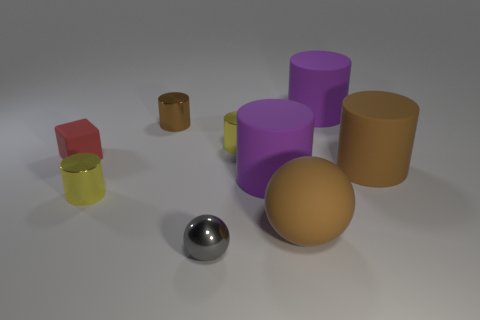What color is the other large thing that is the same shape as the gray metal object?
Make the answer very short. Brown. How many large objects are matte cylinders or red things?
Offer a very short reply. 3. There is a metallic cylinder right of the gray object; how big is it?
Offer a terse response. Small. Is there a tiny rubber ball that has the same color as the shiny sphere?
Provide a short and direct response. No. Is the large rubber sphere the same color as the tiny ball?
Your response must be concise. No. The small metallic thing that is the same color as the rubber sphere is what shape?
Give a very brief answer. Cylinder. What number of small yellow metallic cylinders are on the left side of the small shiny object that is right of the tiny ball?
Your answer should be very brief. 1. How many purple cylinders have the same material as the big sphere?
Your response must be concise. 2. There is a brown rubber cylinder; are there any small metallic cylinders in front of it?
Offer a very short reply. Yes. The metal ball that is the same size as the red matte thing is what color?
Ensure brevity in your answer.  Gray. 